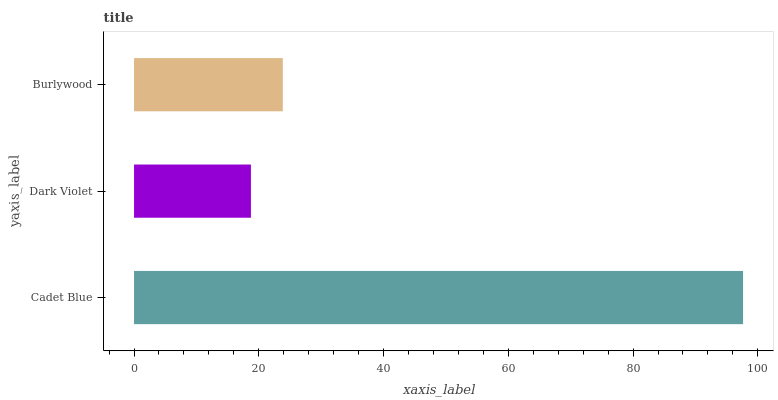Is Dark Violet the minimum?
Answer yes or no. Yes. Is Cadet Blue the maximum?
Answer yes or no. Yes. Is Burlywood the minimum?
Answer yes or no. No. Is Burlywood the maximum?
Answer yes or no. No. Is Burlywood greater than Dark Violet?
Answer yes or no. Yes. Is Dark Violet less than Burlywood?
Answer yes or no. Yes. Is Dark Violet greater than Burlywood?
Answer yes or no. No. Is Burlywood less than Dark Violet?
Answer yes or no. No. Is Burlywood the high median?
Answer yes or no. Yes. Is Burlywood the low median?
Answer yes or no. Yes. Is Cadet Blue the high median?
Answer yes or no. No. Is Dark Violet the low median?
Answer yes or no. No. 